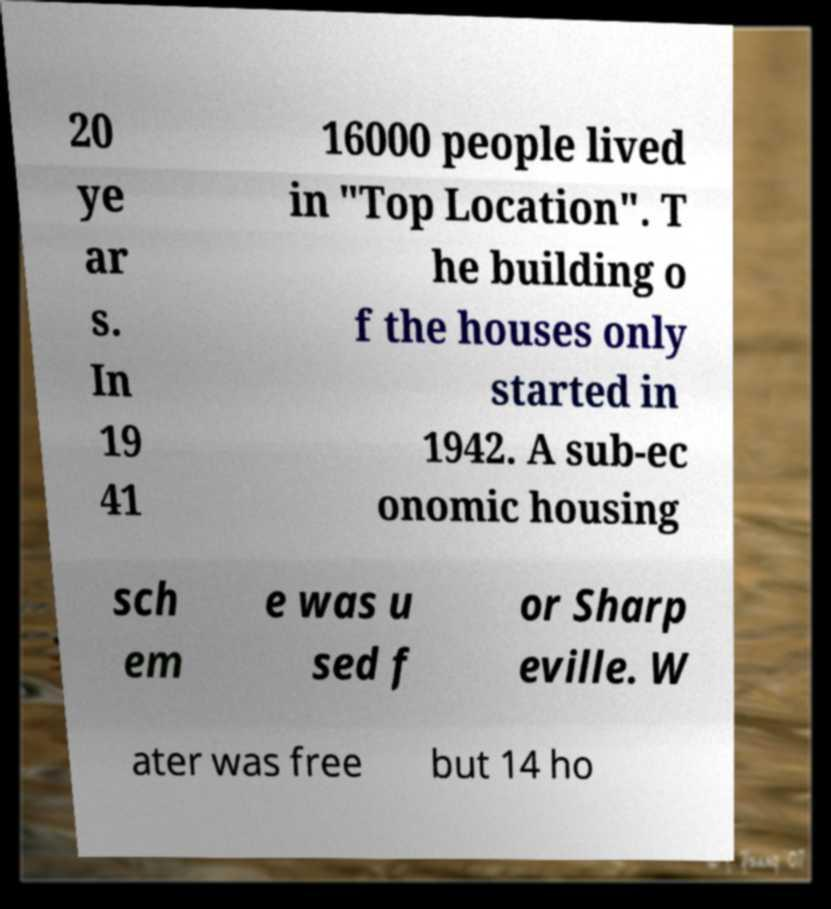Can you accurately transcribe the text from the provided image for me? 20 ye ar s. In 19 41 16000 people lived in "Top Location". T he building o f the houses only started in 1942. A sub-ec onomic housing sch em e was u sed f or Sharp eville. W ater was free but 14 ho 